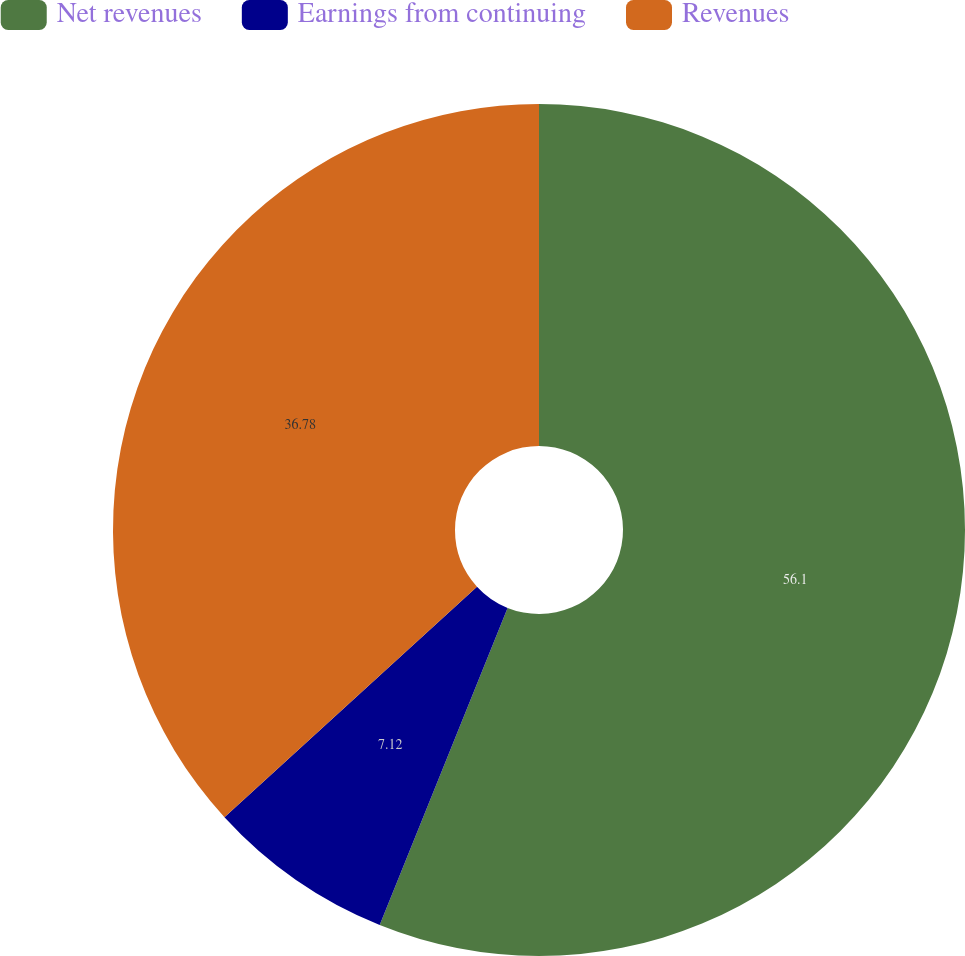Convert chart to OTSL. <chart><loc_0><loc_0><loc_500><loc_500><pie_chart><fcel>Net revenues<fcel>Earnings from continuing<fcel>Revenues<nl><fcel>56.1%<fcel>7.12%<fcel>36.78%<nl></chart> 